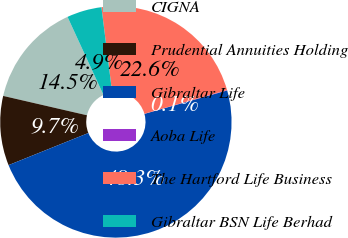Convert chart. <chart><loc_0><loc_0><loc_500><loc_500><pie_chart><fcel>CIGNA<fcel>Prudential Annuities Holding<fcel>Gibraltar Life<fcel>Aoba Life<fcel>The Hartford Life Business<fcel>Gibraltar BSN Life Berhad<nl><fcel>14.52%<fcel>9.7%<fcel>48.3%<fcel>0.05%<fcel>22.55%<fcel>4.87%<nl></chart> 